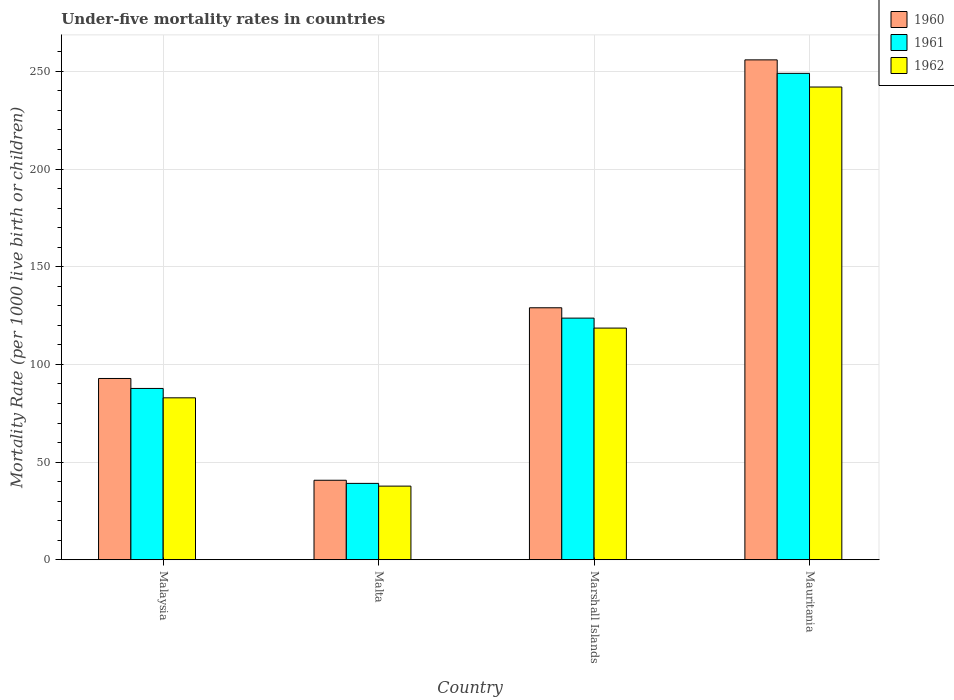How many groups of bars are there?
Offer a very short reply. 4. Are the number of bars on each tick of the X-axis equal?
Offer a very short reply. Yes. How many bars are there on the 4th tick from the left?
Make the answer very short. 3. What is the label of the 4th group of bars from the left?
Give a very brief answer. Mauritania. What is the under-five mortality rate in 1960 in Mauritania?
Give a very brief answer. 255.9. Across all countries, what is the maximum under-five mortality rate in 1960?
Provide a succinct answer. 255.9. Across all countries, what is the minimum under-five mortality rate in 1961?
Give a very brief answer. 39.1. In which country was the under-five mortality rate in 1961 maximum?
Make the answer very short. Mauritania. In which country was the under-five mortality rate in 1961 minimum?
Make the answer very short. Malta. What is the total under-five mortality rate in 1961 in the graph?
Provide a short and direct response. 499.5. What is the difference between the under-five mortality rate in 1960 in Malta and that in Marshall Islands?
Offer a very short reply. -88.3. What is the difference between the under-five mortality rate in 1962 in Marshall Islands and the under-five mortality rate in 1961 in Malta?
Provide a short and direct response. 79.5. What is the average under-five mortality rate in 1961 per country?
Your response must be concise. 124.88. What is the difference between the under-five mortality rate of/in 1962 and under-five mortality rate of/in 1961 in Malaysia?
Make the answer very short. -4.8. In how many countries, is the under-five mortality rate in 1962 greater than 200?
Provide a succinct answer. 1. What is the ratio of the under-five mortality rate in 1960 in Malaysia to that in Mauritania?
Keep it short and to the point. 0.36. What is the difference between the highest and the second highest under-five mortality rate in 1961?
Provide a short and direct response. 125.3. What is the difference between the highest and the lowest under-five mortality rate in 1961?
Make the answer very short. 209.9. Is the sum of the under-five mortality rate in 1961 in Marshall Islands and Mauritania greater than the maximum under-five mortality rate in 1960 across all countries?
Ensure brevity in your answer.  Yes. What does the 2nd bar from the left in Marshall Islands represents?
Give a very brief answer. 1961. How many bars are there?
Your response must be concise. 12. Are all the bars in the graph horizontal?
Make the answer very short. No. How many countries are there in the graph?
Keep it short and to the point. 4. Are the values on the major ticks of Y-axis written in scientific E-notation?
Your answer should be compact. No. Does the graph contain grids?
Give a very brief answer. Yes. How many legend labels are there?
Your response must be concise. 3. How are the legend labels stacked?
Make the answer very short. Vertical. What is the title of the graph?
Make the answer very short. Under-five mortality rates in countries. Does "1975" appear as one of the legend labels in the graph?
Your answer should be very brief. No. What is the label or title of the X-axis?
Provide a short and direct response. Country. What is the label or title of the Y-axis?
Offer a very short reply. Mortality Rate (per 1000 live birth or children). What is the Mortality Rate (per 1000 live birth or children) in 1960 in Malaysia?
Give a very brief answer. 92.8. What is the Mortality Rate (per 1000 live birth or children) in 1961 in Malaysia?
Make the answer very short. 87.7. What is the Mortality Rate (per 1000 live birth or children) in 1962 in Malaysia?
Give a very brief answer. 82.9. What is the Mortality Rate (per 1000 live birth or children) in 1960 in Malta?
Ensure brevity in your answer.  40.7. What is the Mortality Rate (per 1000 live birth or children) of 1961 in Malta?
Your response must be concise. 39.1. What is the Mortality Rate (per 1000 live birth or children) of 1962 in Malta?
Offer a terse response. 37.7. What is the Mortality Rate (per 1000 live birth or children) of 1960 in Marshall Islands?
Ensure brevity in your answer.  129. What is the Mortality Rate (per 1000 live birth or children) of 1961 in Marshall Islands?
Provide a short and direct response. 123.7. What is the Mortality Rate (per 1000 live birth or children) of 1962 in Marshall Islands?
Make the answer very short. 118.6. What is the Mortality Rate (per 1000 live birth or children) in 1960 in Mauritania?
Your answer should be very brief. 255.9. What is the Mortality Rate (per 1000 live birth or children) of 1961 in Mauritania?
Your response must be concise. 249. What is the Mortality Rate (per 1000 live birth or children) of 1962 in Mauritania?
Your response must be concise. 242. Across all countries, what is the maximum Mortality Rate (per 1000 live birth or children) of 1960?
Your answer should be very brief. 255.9. Across all countries, what is the maximum Mortality Rate (per 1000 live birth or children) of 1961?
Make the answer very short. 249. Across all countries, what is the maximum Mortality Rate (per 1000 live birth or children) of 1962?
Your answer should be very brief. 242. Across all countries, what is the minimum Mortality Rate (per 1000 live birth or children) in 1960?
Offer a terse response. 40.7. Across all countries, what is the minimum Mortality Rate (per 1000 live birth or children) of 1961?
Your answer should be very brief. 39.1. Across all countries, what is the minimum Mortality Rate (per 1000 live birth or children) in 1962?
Your answer should be very brief. 37.7. What is the total Mortality Rate (per 1000 live birth or children) in 1960 in the graph?
Provide a succinct answer. 518.4. What is the total Mortality Rate (per 1000 live birth or children) in 1961 in the graph?
Keep it short and to the point. 499.5. What is the total Mortality Rate (per 1000 live birth or children) of 1962 in the graph?
Your answer should be very brief. 481.2. What is the difference between the Mortality Rate (per 1000 live birth or children) of 1960 in Malaysia and that in Malta?
Offer a very short reply. 52.1. What is the difference between the Mortality Rate (per 1000 live birth or children) in 1961 in Malaysia and that in Malta?
Your response must be concise. 48.6. What is the difference between the Mortality Rate (per 1000 live birth or children) of 1962 in Malaysia and that in Malta?
Your answer should be compact. 45.2. What is the difference between the Mortality Rate (per 1000 live birth or children) in 1960 in Malaysia and that in Marshall Islands?
Your answer should be very brief. -36.2. What is the difference between the Mortality Rate (per 1000 live birth or children) in 1961 in Malaysia and that in Marshall Islands?
Provide a short and direct response. -36. What is the difference between the Mortality Rate (per 1000 live birth or children) of 1962 in Malaysia and that in Marshall Islands?
Your answer should be compact. -35.7. What is the difference between the Mortality Rate (per 1000 live birth or children) of 1960 in Malaysia and that in Mauritania?
Your answer should be very brief. -163.1. What is the difference between the Mortality Rate (per 1000 live birth or children) in 1961 in Malaysia and that in Mauritania?
Offer a very short reply. -161.3. What is the difference between the Mortality Rate (per 1000 live birth or children) in 1962 in Malaysia and that in Mauritania?
Ensure brevity in your answer.  -159.1. What is the difference between the Mortality Rate (per 1000 live birth or children) of 1960 in Malta and that in Marshall Islands?
Provide a short and direct response. -88.3. What is the difference between the Mortality Rate (per 1000 live birth or children) of 1961 in Malta and that in Marshall Islands?
Give a very brief answer. -84.6. What is the difference between the Mortality Rate (per 1000 live birth or children) in 1962 in Malta and that in Marshall Islands?
Provide a succinct answer. -80.9. What is the difference between the Mortality Rate (per 1000 live birth or children) in 1960 in Malta and that in Mauritania?
Make the answer very short. -215.2. What is the difference between the Mortality Rate (per 1000 live birth or children) of 1961 in Malta and that in Mauritania?
Keep it short and to the point. -209.9. What is the difference between the Mortality Rate (per 1000 live birth or children) in 1962 in Malta and that in Mauritania?
Keep it short and to the point. -204.3. What is the difference between the Mortality Rate (per 1000 live birth or children) in 1960 in Marshall Islands and that in Mauritania?
Provide a succinct answer. -126.9. What is the difference between the Mortality Rate (per 1000 live birth or children) of 1961 in Marshall Islands and that in Mauritania?
Ensure brevity in your answer.  -125.3. What is the difference between the Mortality Rate (per 1000 live birth or children) of 1962 in Marshall Islands and that in Mauritania?
Provide a short and direct response. -123.4. What is the difference between the Mortality Rate (per 1000 live birth or children) of 1960 in Malaysia and the Mortality Rate (per 1000 live birth or children) of 1961 in Malta?
Offer a very short reply. 53.7. What is the difference between the Mortality Rate (per 1000 live birth or children) of 1960 in Malaysia and the Mortality Rate (per 1000 live birth or children) of 1962 in Malta?
Give a very brief answer. 55.1. What is the difference between the Mortality Rate (per 1000 live birth or children) of 1961 in Malaysia and the Mortality Rate (per 1000 live birth or children) of 1962 in Malta?
Give a very brief answer. 50. What is the difference between the Mortality Rate (per 1000 live birth or children) in 1960 in Malaysia and the Mortality Rate (per 1000 live birth or children) in 1961 in Marshall Islands?
Provide a short and direct response. -30.9. What is the difference between the Mortality Rate (per 1000 live birth or children) of 1960 in Malaysia and the Mortality Rate (per 1000 live birth or children) of 1962 in Marshall Islands?
Ensure brevity in your answer.  -25.8. What is the difference between the Mortality Rate (per 1000 live birth or children) of 1961 in Malaysia and the Mortality Rate (per 1000 live birth or children) of 1962 in Marshall Islands?
Keep it short and to the point. -30.9. What is the difference between the Mortality Rate (per 1000 live birth or children) in 1960 in Malaysia and the Mortality Rate (per 1000 live birth or children) in 1961 in Mauritania?
Provide a short and direct response. -156.2. What is the difference between the Mortality Rate (per 1000 live birth or children) of 1960 in Malaysia and the Mortality Rate (per 1000 live birth or children) of 1962 in Mauritania?
Your answer should be very brief. -149.2. What is the difference between the Mortality Rate (per 1000 live birth or children) of 1961 in Malaysia and the Mortality Rate (per 1000 live birth or children) of 1962 in Mauritania?
Offer a terse response. -154.3. What is the difference between the Mortality Rate (per 1000 live birth or children) of 1960 in Malta and the Mortality Rate (per 1000 live birth or children) of 1961 in Marshall Islands?
Your response must be concise. -83. What is the difference between the Mortality Rate (per 1000 live birth or children) in 1960 in Malta and the Mortality Rate (per 1000 live birth or children) in 1962 in Marshall Islands?
Offer a terse response. -77.9. What is the difference between the Mortality Rate (per 1000 live birth or children) in 1961 in Malta and the Mortality Rate (per 1000 live birth or children) in 1962 in Marshall Islands?
Your answer should be compact. -79.5. What is the difference between the Mortality Rate (per 1000 live birth or children) of 1960 in Malta and the Mortality Rate (per 1000 live birth or children) of 1961 in Mauritania?
Offer a terse response. -208.3. What is the difference between the Mortality Rate (per 1000 live birth or children) in 1960 in Malta and the Mortality Rate (per 1000 live birth or children) in 1962 in Mauritania?
Give a very brief answer. -201.3. What is the difference between the Mortality Rate (per 1000 live birth or children) in 1961 in Malta and the Mortality Rate (per 1000 live birth or children) in 1962 in Mauritania?
Ensure brevity in your answer.  -202.9. What is the difference between the Mortality Rate (per 1000 live birth or children) of 1960 in Marshall Islands and the Mortality Rate (per 1000 live birth or children) of 1961 in Mauritania?
Offer a terse response. -120. What is the difference between the Mortality Rate (per 1000 live birth or children) of 1960 in Marshall Islands and the Mortality Rate (per 1000 live birth or children) of 1962 in Mauritania?
Your answer should be compact. -113. What is the difference between the Mortality Rate (per 1000 live birth or children) of 1961 in Marshall Islands and the Mortality Rate (per 1000 live birth or children) of 1962 in Mauritania?
Your answer should be very brief. -118.3. What is the average Mortality Rate (per 1000 live birth or children) in 1960 per country?
Your response must be concise. 129.6. What is the average Mortality Rate (per 1000 live birth or children) in 1961 per country?
Make the answer very short. 124.88. What is the average Mortality Rate (per 1000 live birth or children) in 1962 per country?
Offer a very short reply. 120.3. What is the difference between the Mortality Rate (per 1000 live birth or children) of 1960 and Mortality Rate (per 1000 live birth or children) of 1961 in Malaysia?
Offer a very short reply. 5.1. What is the difference between the Mortality Rate (per 1000 live birth or children) of 1960 and Mortality Rate (per 1000 live birth or children) of 1962 in Malaysia?
Ensure brevity in your answer.  9.9. What is the difference between the Mortality Rate (per 1000 live birth or children) of 1961 and Mortality Rate (per 1000 live birth or children) of 1962 in Malaysia?
Provide a short and direct response. 4.8. What is the difference between the Mortality Rate (per 1000 live birth or children) of 1960 and Mortality Rate (per 1000 live birth or children) of 1961 in Malta?
Make the answer very short. 1.6. What is the difference between the Mortality Rate (per 1000 live birth or children) in 1960 and Mortality Rate (per 1000 live birth or children) in 1962 in Malta?
Your response must be concise. 3. What is the difference between the Mortality Rate (per 1000 live birth or children) of 1960 and Mortality Rate (per 1000 live birth or children) of 1961 in Marshall Islands?
Make the answer very short. 5.3. What is the difference between the Mortality Rate (per 1000 live birth or children) of 1961 and Mortality Rate (per 1000 live birth or children) of 1962 in Mauritania?
Offer a terse response. 7. What is the ratio of the Mortality Rate (per 1000 live birth or children) of 1960 in Malaysia to that in Malta?
Offer a very short reply. 2.28. What is the ratio of the Mortality Rate (per 1000 live birth or children) in 1961 in Malaysia to that in Malta?
Your answer should be compact. 2.24. What is the ratio of the Mortality Rate (per 1000 live birth or children) of 1962 in Malaysia to that in Malta?
Provide a short and direct response. 2.2. What is the ratio of the Mortality Rate (per 1000 live birth or children) in 1960 in Malaysia to that in Marshall Islands?
Your answer should be compact. 0.72. What is the ratio of the Mortality Rate (per 1000 live birth or children) in 1961 in Malaysia to that in Marshall Islands?
Give a very brief answer. 0.71. What is the ratio of the Mortality Rate (per 1000 live birth or children) of 1962 in Malaysia to that in Marshall Islands?
Provide a succinct answer. 0.7. What is the ratio of the Mortality Rate (per 1000 live birth or children) of 1960 in Malaysia to that in Mauritania?
Ensure brevity in your answer.  0.36. What is the ratio of the Mortality Rate (per 1000 live birth or children) of 1961 in Malaysia to that in Mauritania?
Provide a short and direct response. 0.35. What is the ratio of the Mortality Rate (per 1000 live birth or children) in 1962 in Malaysia to that in Mauritania?
Provide a short and direct response. 0.34. What is the ratio of the Mortality Rate (per 1000 live birth or children) in 1960 in Malta to that in Marshall Islands?
Make the answer very short. 0.32. What is the ratio of the Mortality Rate (per 1000 live birth or children) in 1961 in Malta to that in Marshall Islands?
Your answer should be compact. 0.32. What is the ratio of the Mortality Rate (per 1000 live birth or children) of 1962 in Malta to that in Marshall Islands?
Your response must be concise. 0.32. What is the ratio of the Mortality Rate (per 1000 live birth or children) of 1960 in Malta to that in Mauritania?
Your answer should be compact. 0.16. What is the ratio of the Mortality Rate (per 1000 live birth or children) of 1961 in Malta to that in Mauritania?
Your answer should be compact. 0.16. What is the ratio of the Mortality Rate (per 1000 live birth or children) in 1962 in Malta to that in Mauritania?
Keep it short and to the point. 0.16. What is the ratio of the Mortality Rate (per 1000 live birth or children) in 1960 in Marshall Islands to that in Mauritania?
Offer a very short reply. 0.5. What is the ratio of the Mortality Rate (per 1000 live birth or children) of 1961 in Marshall Islands to that in Mauritania?
Offer a terse response. 0.5. What is the ratio of the Mortality Rate (per 1000 live birth or children) in 1962 in Marshall Islands to that in Mauritania?
Your response must be concise. 0.49. What is the difference between the highest and the second highest Mortality Rate (per 1000 live birth or children) in 1960?
Provide a succinct answer. 126.9. What is the difference between the highest and the second highest Mortality Rate (per 1000 live birth or children) in 1961?
Ensure brevity in your answer.  125.3. What is the difference between the highest and the second highest Mortality Rate (per 1000 live birth or children) in 1962?
Provide a succinct answer. 123.4. What is the difference between the highest and the lowest Mortality Rate (per 1000 live birth or children) of 1960?
Give a very brief answer. 215.2. What is the difference between the highest and the lowest Mortality Rate (per 1000 live birth or children) in 1961?
Your answer should be very brief. 209.9. What is the difference between the highest and the lowest Mortality Rate (per 1000 live birth or children) in 1962?
Your answer should be very brief. 204.3. 